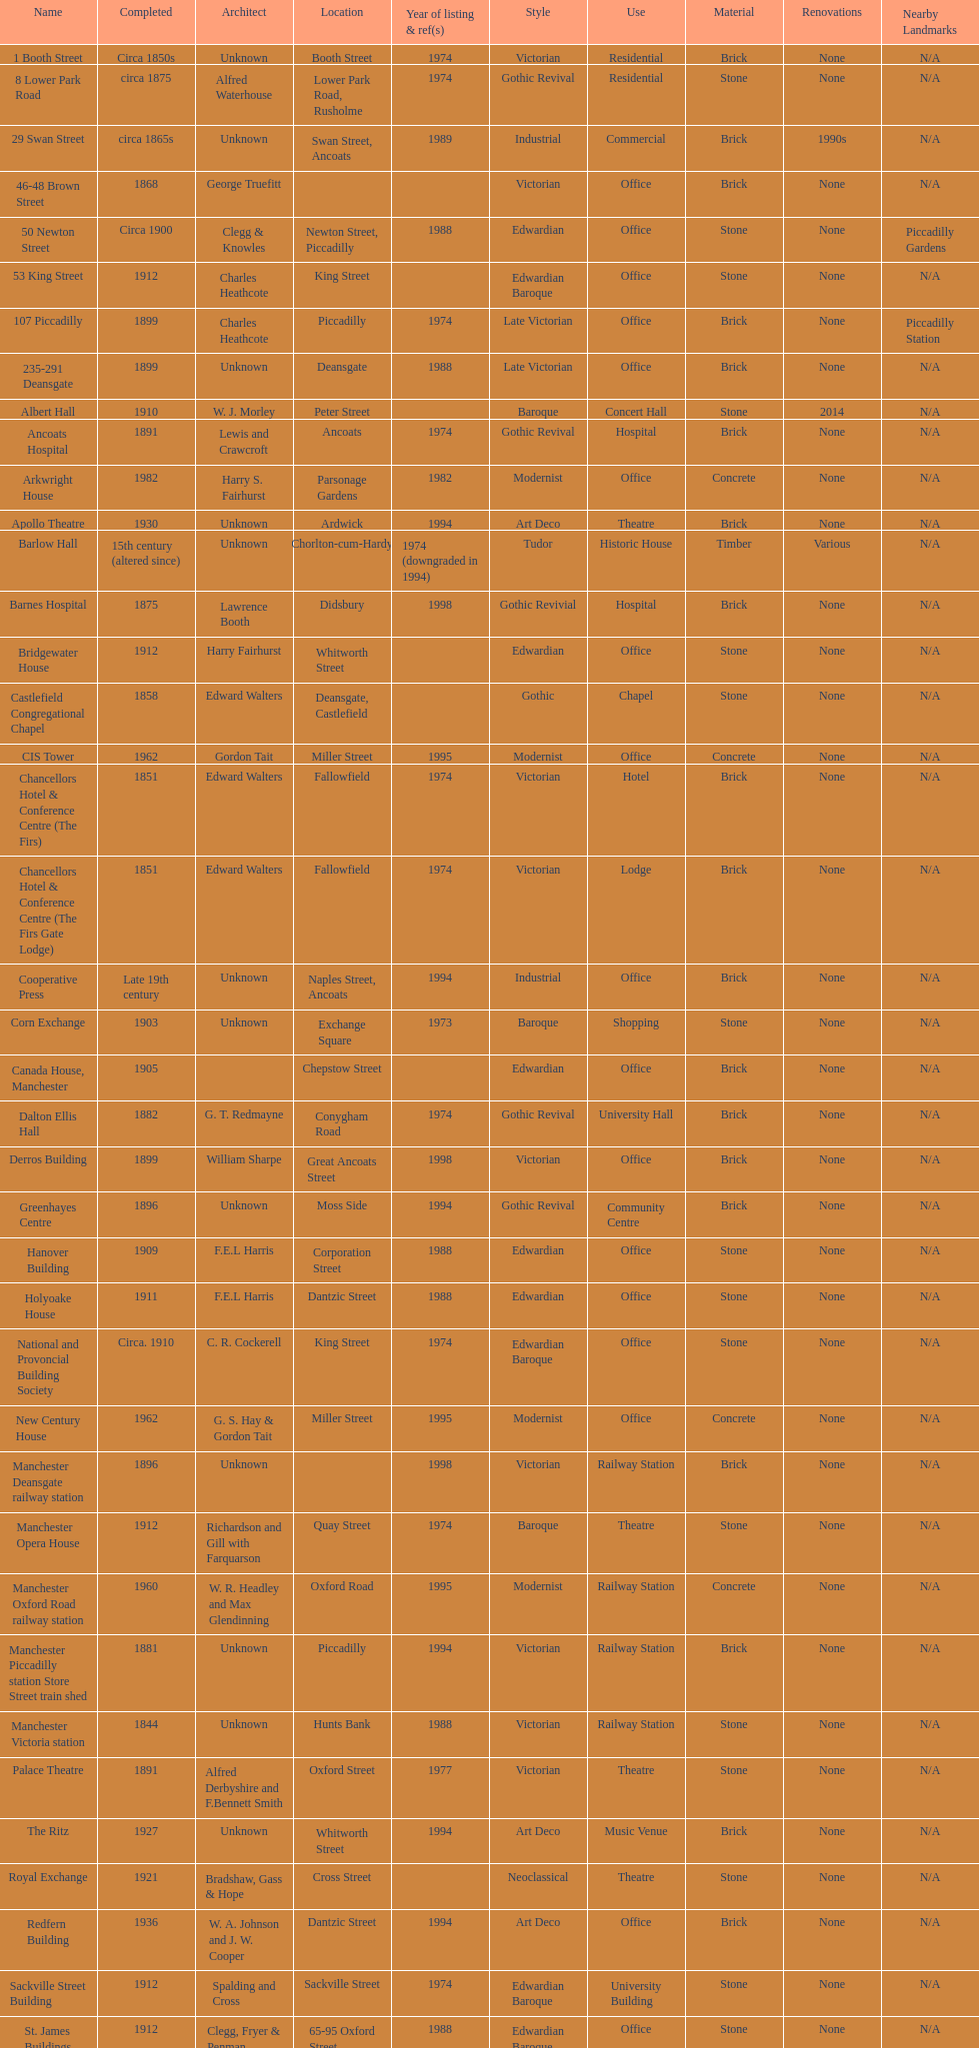Give me the full table as a dictionary. {'header': ['Name', 'Completed', 'Architect', 'Location', 'Year of listing & ref(s)', 'Style', 'Use', 'Material', 'Renovations', 'Nearby Landmarks'], 'rows': [['1 Booth Street', 'Circa 1850s', 'Unknown', 'Booth Street', '1974', 'Victorian', 'Residential', 'Brick', 'None', 'N/A'], ['8 Lower Park Road', 'circa 1875', 'Alfred Waterhouse', 'Lower Park Road, Rusholme', '1974', 'Gothic Revival', 'Residential', 'Stone', 'None', 'N/A'], ['29 Swan Street', 'circa 1865s', 'Unknown', 'Swan Street, Ancoats', '1989', 'Industrial', 'Commercial', 'Brick', '1990s', 'N/A'], ['46-48 Brown Street', '1868', 'George Truefitt', '', '', 'Victorian', 'Office', 'Brick', 'None', 'N/A'], ['50 Newton Street', 'Circa 1900', 'Clegg & Knowles', 'Newton Street, Piccadilly', '1988', 'Edwardian', 'Office', 'Stone', 'None', 'Piccadilly Gardens'], ['53 King Street', '1912', 'Charles Heathcote', 'King Street', '', 'Edwardian Baroque', 'Office', 'Stone', 'None', 'N/A'], ['107 Piccadilly', '1899', 'Charles Heathcote', 'Piccadilly', '1974', 'Late Victorian', 'Office', 'Brick', 'None', 'Piccadilly Station'], ['235-291 Deansgate', '1899', 'Unknown', 'Deansgate', '1988', 'Late Victorian', 'Office', 'Brick', 'None', 'N/A'], ['Albert Hall', '1910', 'W. J. Morley', 'Peter Street', '', 'Baroque', 'Concert Hall', 'Stone', '2014', 'N/A'], ['Ancoats Hospital', '1891', 'Lewis and Crawcroft', 'Ancoats', '1974', 'Gothic Revival', 'Hospital', 'Brick', 'None', 'N/A'], ['Arkwright House', '1982', 'Harry S. Fairhurst', 'Parsonage Gardens', '1982', 'Modernist', 'Office', 'Concrete', 'None', 'N/A'], ['Apollo Theatre', '1930', 'Unknown', 'Ardwick', '1994', 'Art Deco', 'Theatre', 'Brick', 'None', 'N/A'], ['Barlow Hall', '15th century (altered since)', 'Unknown', 'Chorlton-cum-Hardy', '1974 (downgraded in 1994)', 'Tudor', 'Historic House', 'Timber', 'Various', 'N/A'], ['Barnes Hospital', '1875', 'Lawrence Booth', 'Didsbury', '1998', 'Gothic Revivial', 'Hospital', 'Brick', 'None', 'N/A'], ['Bridgewater House', '1912', 'Harry Fairhurst', 'Whitworth Street', '', 'Edwardian', 'Office', 'Stone', 'None', 'N/A'], ['Castlefield Congregational Chapel', '1858', 'Edward Walters', 'Deansgate, Castlefield', '', 'Gothic', 'Chapel', 'Stone', 'None', 'N/A'], ['CIS Tower', '1962', 'Gordon Tait', 'Miller Street', '1995', 'Modernist', 'Office', 'Concrete', 'None', 'N/A'], ['Chancellors Hotel & Conference Centre (The Firs)', '1851', 'Edward Walters', 'Fallowfield', '1974', 'Victorian', 'Hotel', 'Brick', 'None', 'N/A'], ['Chancellors Hotel & Conference Centre (The Firs Gate Lodge)', '1851', 'Edward Walters', 'Fallowfield', '1974', 'Victorian', 'Lodge', 'Brick', 'None', 'N/A'], ['Cooperative Press', 'Late 19th century', 'Unknown', 'Naples Street, Ancoats', '1994', 'Industrial', 'Office', 'Brick', 'None', 'N/A'], ['Corn Exchange', '1903', 'Unknown', 'Exchange Square', '1973', 'Baroque', 'Shopping', 'Stone', 'None', 'N/A'], ['Canada House, Manchester', '1905', '', 'Chepstow Street', '', 'Edwardian', 'Office', 'Brick', 'None', 'N/A'], ['Dalton Ellis Hall', '1882', 'G. T. Redmayne', 'Conygham Road', '1974', 'Gothic Revival', 'University Hall', 'Brick', 'None', 'N/A'], ['Derros Building', '1899', 'William Sharpe', 'Great Ancoats Street', '1998', 'Victorian', 'Office', 'Brick', 'None', 'N/A'], ['Greenhayes Centre', '1896', 'Unknown', 'Moss Side', '1994', 'Gothic Revival', 'Community Centre', 'Brick', 'None', 'N/A'], ['Hanover Building', '1909', 'F.E.L Harris', 'Corporation Street', '1988', 'Edwardian', 'Office', 'Stone', 'None', 'N/A'], ['Holyoake House', '1911', 'F.E.L Harris', 'Dantzic Street', '1988', 'Edwardian', 'Office', 'Stone', 'None', 'N/A'], ['National and Provoncial Building Society', 'Circa. 1910', 'C. R. Cockerell', 'King Street', '1974', 'Edwardian Baroque', 'Office', 'Stone', 'None', 'N/A'], ['New Century House', '1962', 'G. S. Hay & Gordon Tait', 'Miller Street', '1995', 'Modernist', 'Office', 'Concrete', 'None', 'N/A'], ['Manchester Deansgate railway station', '1896', 'Unknown', '', '1998', 'Victorian', 'Railway Station', 'Brick', 'None', 'N/A'], ['Manchester Opera House', '1912', 'Richardson and Gill with Farquarson', 'Quay Street', '1974', 'Baroque', 'Theatre', 'Stone', 'None', 'N/A'], ['Manchester Oxford Road railway station', '1960', 'W. R. Headley and Max Glendinning', 'Oxford Road', '1995', 'Modernist', 'Railway Station', 'Concrete', 'None', 'N/A'], ['Manchester Piccadilly station Store Street train shed', '1881', 'Unknown', 'Piccadilly', '1994', 'Victorian', 'Railway Station', 'Brick', 'None', 'N/A'], ['Manchester Victoria station', '1844', 'Unknown', 'Hunts Bank', '1988', 'Victorian', 'Railway Station', 'Stone', 'None', 'N/A'], ['Palace Theatre', '1891', 'Alfred Derbyshire and F.Bennett Smith', 'Oxford Street', '1977', 'Victorian', 'Theatre', 'Stone', 'None', 'N/A'], ['The Ritz', '1927', 'Unknown', 'Whitworth Street', '1994', 'Art Deco', 'Music Venue', 'Brick', 'None', 'N/A'], ['Royal Exchange', '1921', 'Bradshaw, Gass & Hope', 'Cross Street', '', 'Neoclassical', 'Theatre', 'Stone', 'None', 'N/A'], ['Redfern Building', '1936', 'W. A. Johnson and J. W. Cooper', 'Dantzic Street', '1994', 'Art Deco', 'Office', 'Brick', 'None', 'N/A'], ['Sackville Street Building', '1912', 'Spalding and Cross', 'Sackville Street', '1974', 'Edwardian Baroque', 'University Building', 'Stone', 'None', 'N/A'], ['St. James Buildings', '1912', 'Clegg, Fryer & Penman', '65-95 Oxford Street', '1988', 'Edwardian Baroque', 'Office', 'Stone', 'None', 'N/A'], ["St Mary's Hospital", '1909', 'John Ely', 'Wilmslow Road', '1994', 'Edwardian', 'Hospital', 'Brick', 'None', 'N/A'], ['Samuel Alexander Building', '1919', 'Percy Scott Worthington', 'Oxford Road', '2010', 'Edwardian', 'University Building', 'Stone', 'None', 'N/A'], ['Ship Canal House', '1927', 'Harry S. Fairhurst', 'King Street', '1982', 'Art Deco', 'Office', 'Stone', 'None', 'N/A'], ['Smithfield Market Hall', '1857', 'Unknown', 'Swan Street, Ancoats', '1973', 'Victorian', 'Market', 'Brick', 'None', 'N/A'], ['Strangeways Gaol Gatehouse', '1868', 'Alfred Waterhouse', 'Sherborne Street', '1974', 'Gothic Revival', 'Gatehouse', 'Stone', 'None', 'N/A'], ['Strangeways Prison ventilation and watch tower', '1868', 'Alfred Waterhouse', 'Sherborne Street', '1974', 'Gothic Revival', 'Tower', 'Stone', 'None', 'N/A'], ['Theatre Royal', '1845', 'Irwin and Chester', 'Peter Street', '1974', 'Victorian', 'Theatre', 'Stone', 'None', 'N/A'], ['Toast Rack', '1960', 'L. C. Howitt', 'Fallowfield', '1999', 'Modernist', 'Education', 'Concrete', 'None', 'N/A'], ['The Old Wellington Inn', 'Mid-16th century', 'Unknown', 'Shambles Square', '1952', 'Tudor', 'Pub', 'Timber', 'Various', 'N/A'], ['Whitworth Park Mansions', 'Circa 1840s', 'Unknown', 'Whitworth Park', '1974', 'Victorian', 'Residential', 'Brick', 'None', 'N/A']]} Which two buildings were listed before 1974? The Old Wellington Inn, Smithfield Market Hall. 